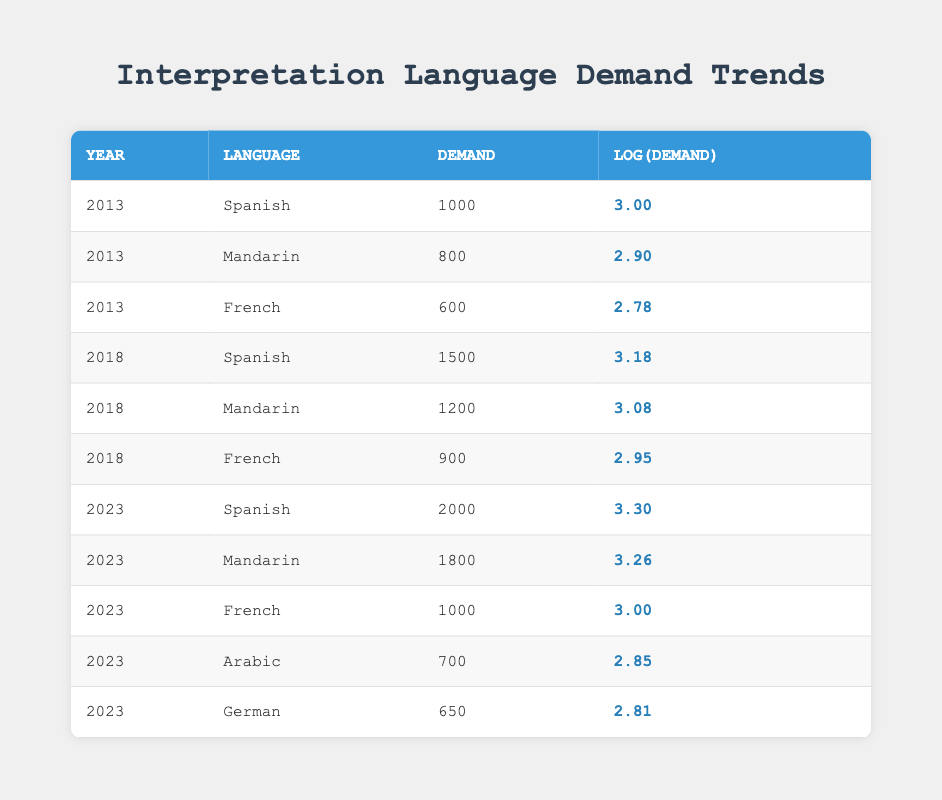What was the demand for Spanish interpretation in 2023? The table shows that in 2023, the demand for Spanish interpretation is listed as 2000.
Answer: 2000 Which language had the highest demand in 2018? By looking at the demand values for 2018, Spanish has the highest value at 1500, compared to Mandarin at 1200 and French at 900.
Answer: Spanish What is the total demand for interpretation languages in 2023? The table shows the demands for the interpretation languages in 2023: Spanish (2000), Mandarin (1800), French (1000), Arabic (700), and German (650). Adding these gives 2000 + 1800 + 1000 + 700 + 650 = 5150.
Answer: 5150 Is the demand for Arabic interpretation higher than German interpretation in 2023? The table states that Arabic has a demand of 700, while German has a demand of 650 in 2023. Therefore, Arabic is higher than German.
Answer: Yes What was the average demand for French interpretation over the years shown in the table? The table lists French demands: 600 (2013), 900 (2018), and 1000 (2023). The average is calculated by summing these values: 600 + 900 + 1000 = 2500, then dividing by the number of entries (3), resulting in 2500 / 3 = 833.33.
Answer: 833.33 